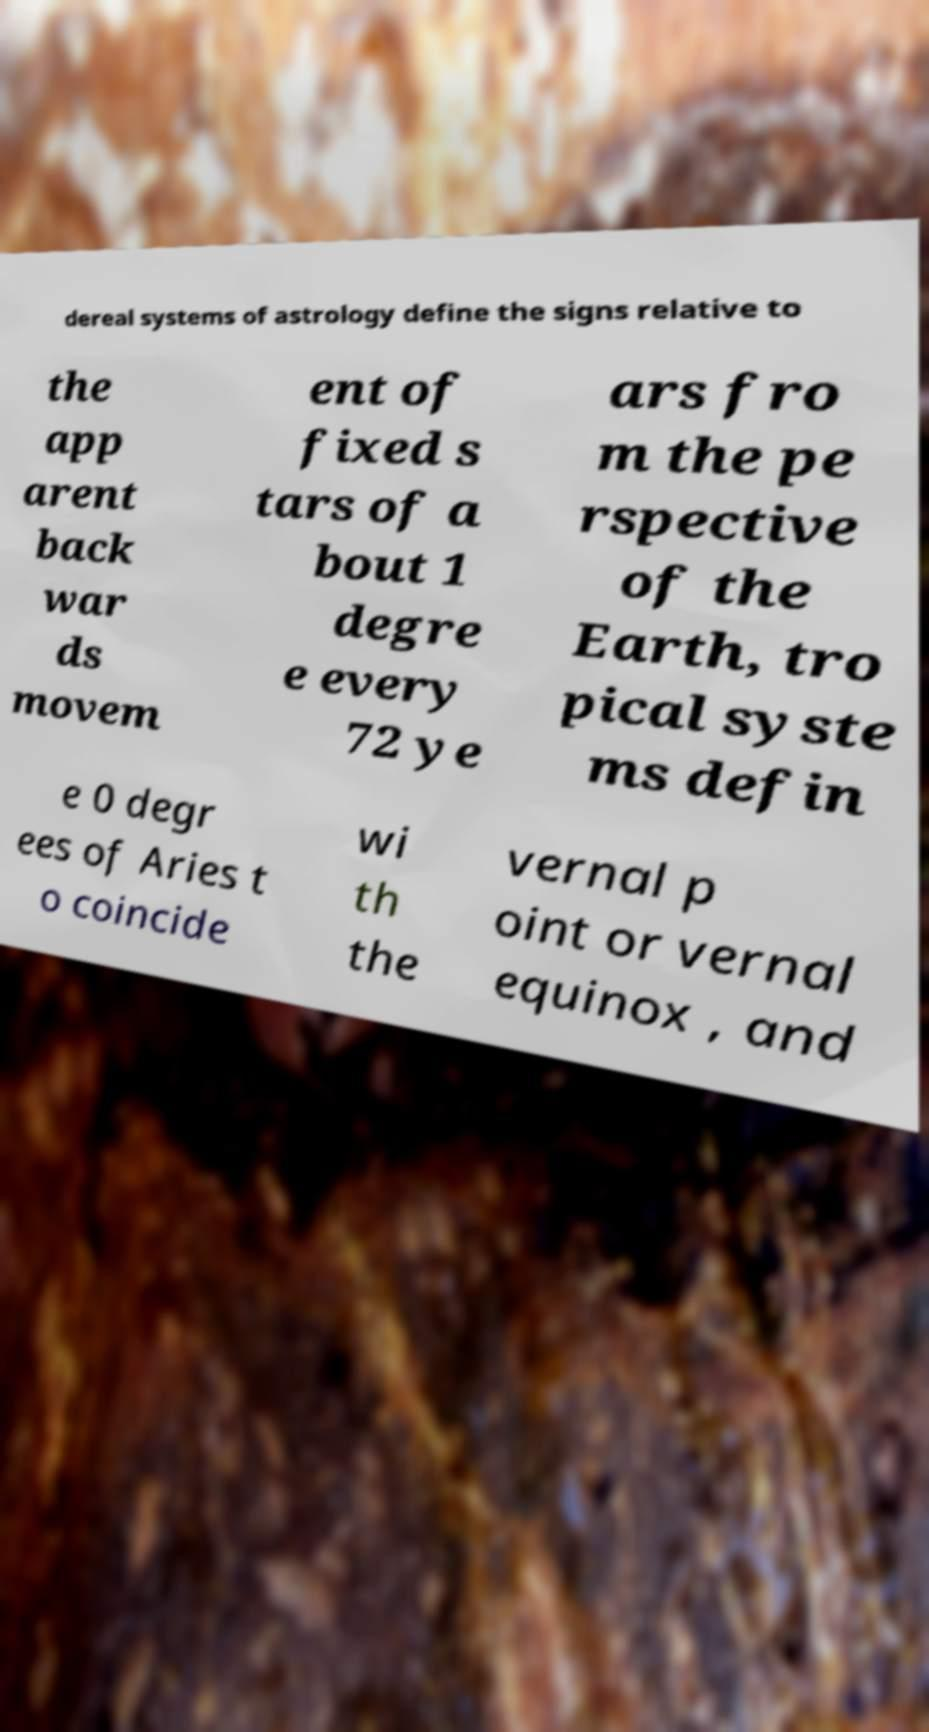For documentation purposes, I need the text within this image transcribed. Could you provide that? dereal systems of astrology define the signs relative to the app arent back war ds movem ent of fixed s tars of a bout 1 degre e every 72 ye ars fro m the pe rspective of the Earth, tro pical syste ms defin e 0 degr ees of Aries t o coincide wi th the vernal p oint or vernal equinox , and 